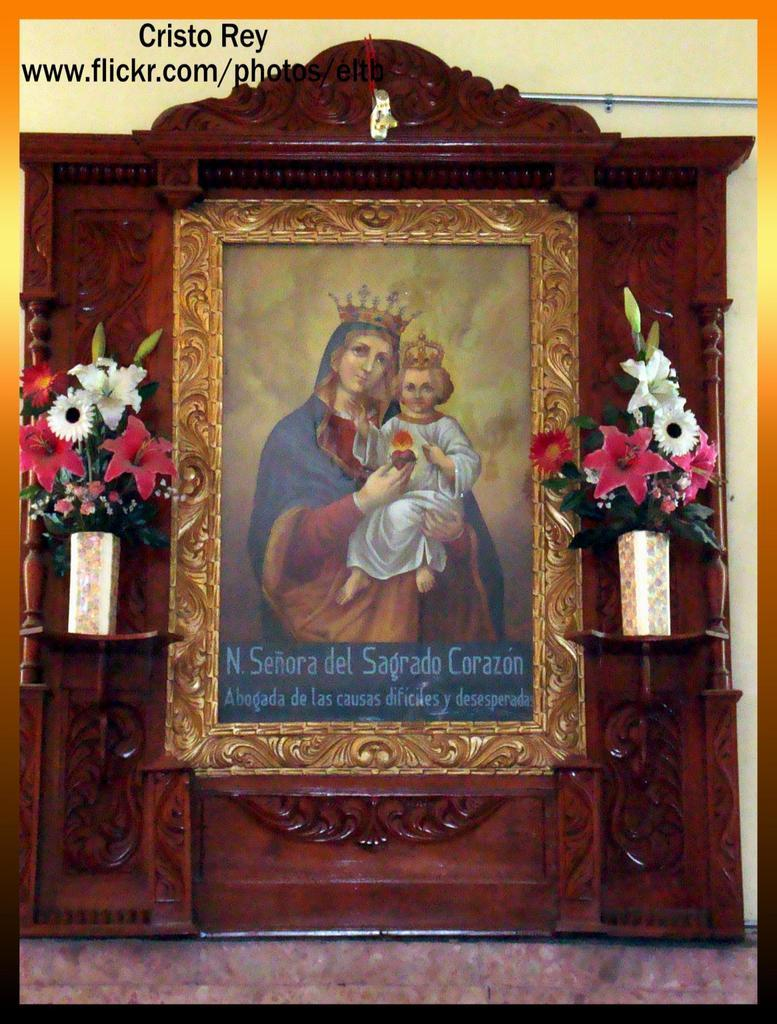<image>
Share a concise interpretation of the image provided. the name cristo is above the holy painting 